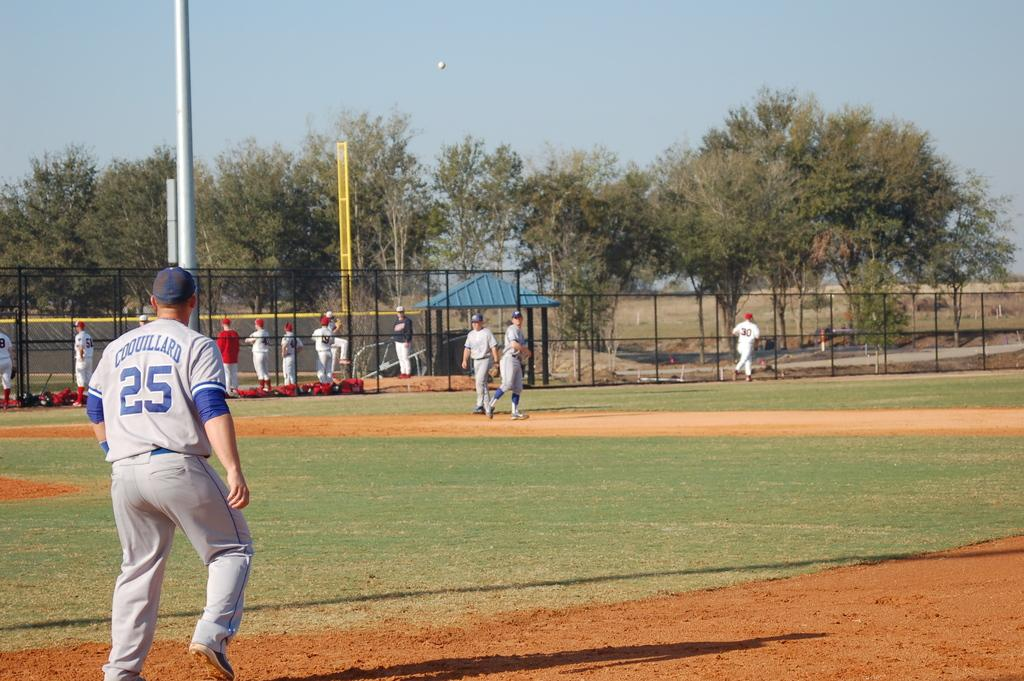<image>
Summarize the visual content of the image. the number 25 on the back of a jersey 